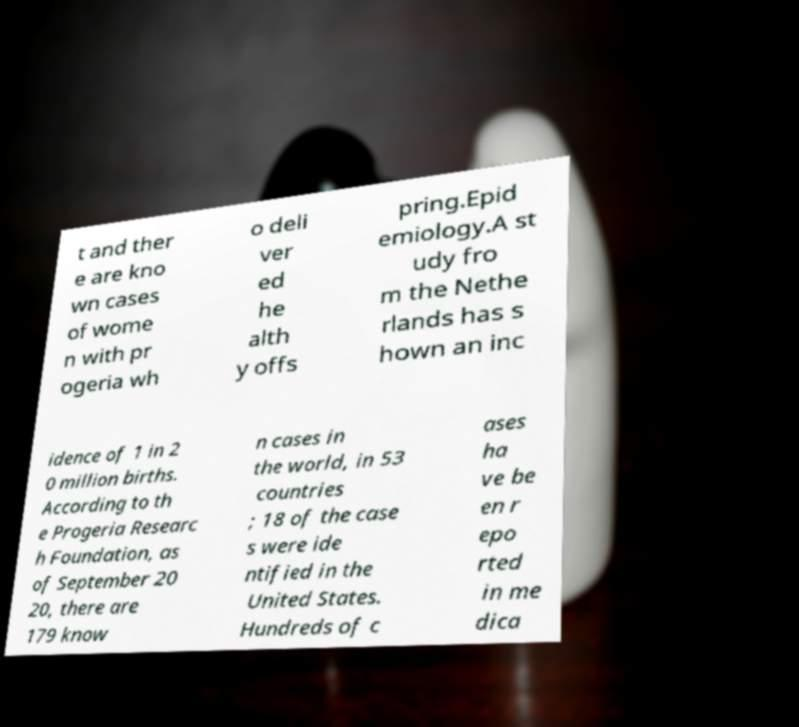What messages or text are displayed in this image? I need them in a readable, typed format. t and ther e are kno wn cases of wome n with pr ogeria wh o deli ver ed he alth y offs pring.Epid emiology.A st udy fro m the Nethe rlands has s hown an inc idence of 1 in 2 0 million births. According to th e Progeria Researc h Foundation, as of September 20 20, there are 179 know n cases in the world, in 53 countries ; 18 of the case s were ide ntified in the United States. Hundreds of c ases ha ve be en r epo rted in me dica 